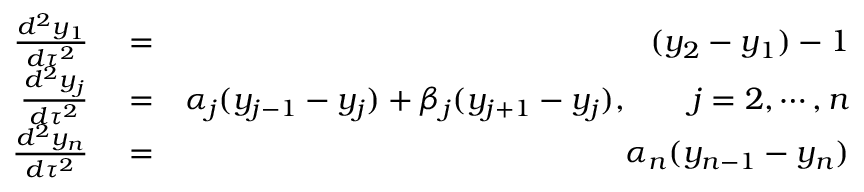Convert formula to latex. <formula><loc_0><loc_0><loc_500><loc_500>\begin{array} { r l r } { \frac { d ^ { 2 } y _ { 1 } } { d \tau ^ { 2 } } } & = } & { ( y _ { 2 } - y _ { 1 } ) - 1 } \\ { \frac { d ^ { 2 } y _ { j } } { d \tau ^ { 2 } } } & = } & { \alpha _ { j } ( y _ { j - 1 } - y _ { j } ) + \beta _ { j } ( y _ { j + 1 } - y _ { j } ) , \quad j = 2 , \cdots , n } \\ { \frac { d ^ { 2 } y _ { n } } { d \tau ^ { 2 } } } & = } & { \alpha _ { n } ( y _ { n - 1 } - y _ { n } ) } \end{array}</formula> 